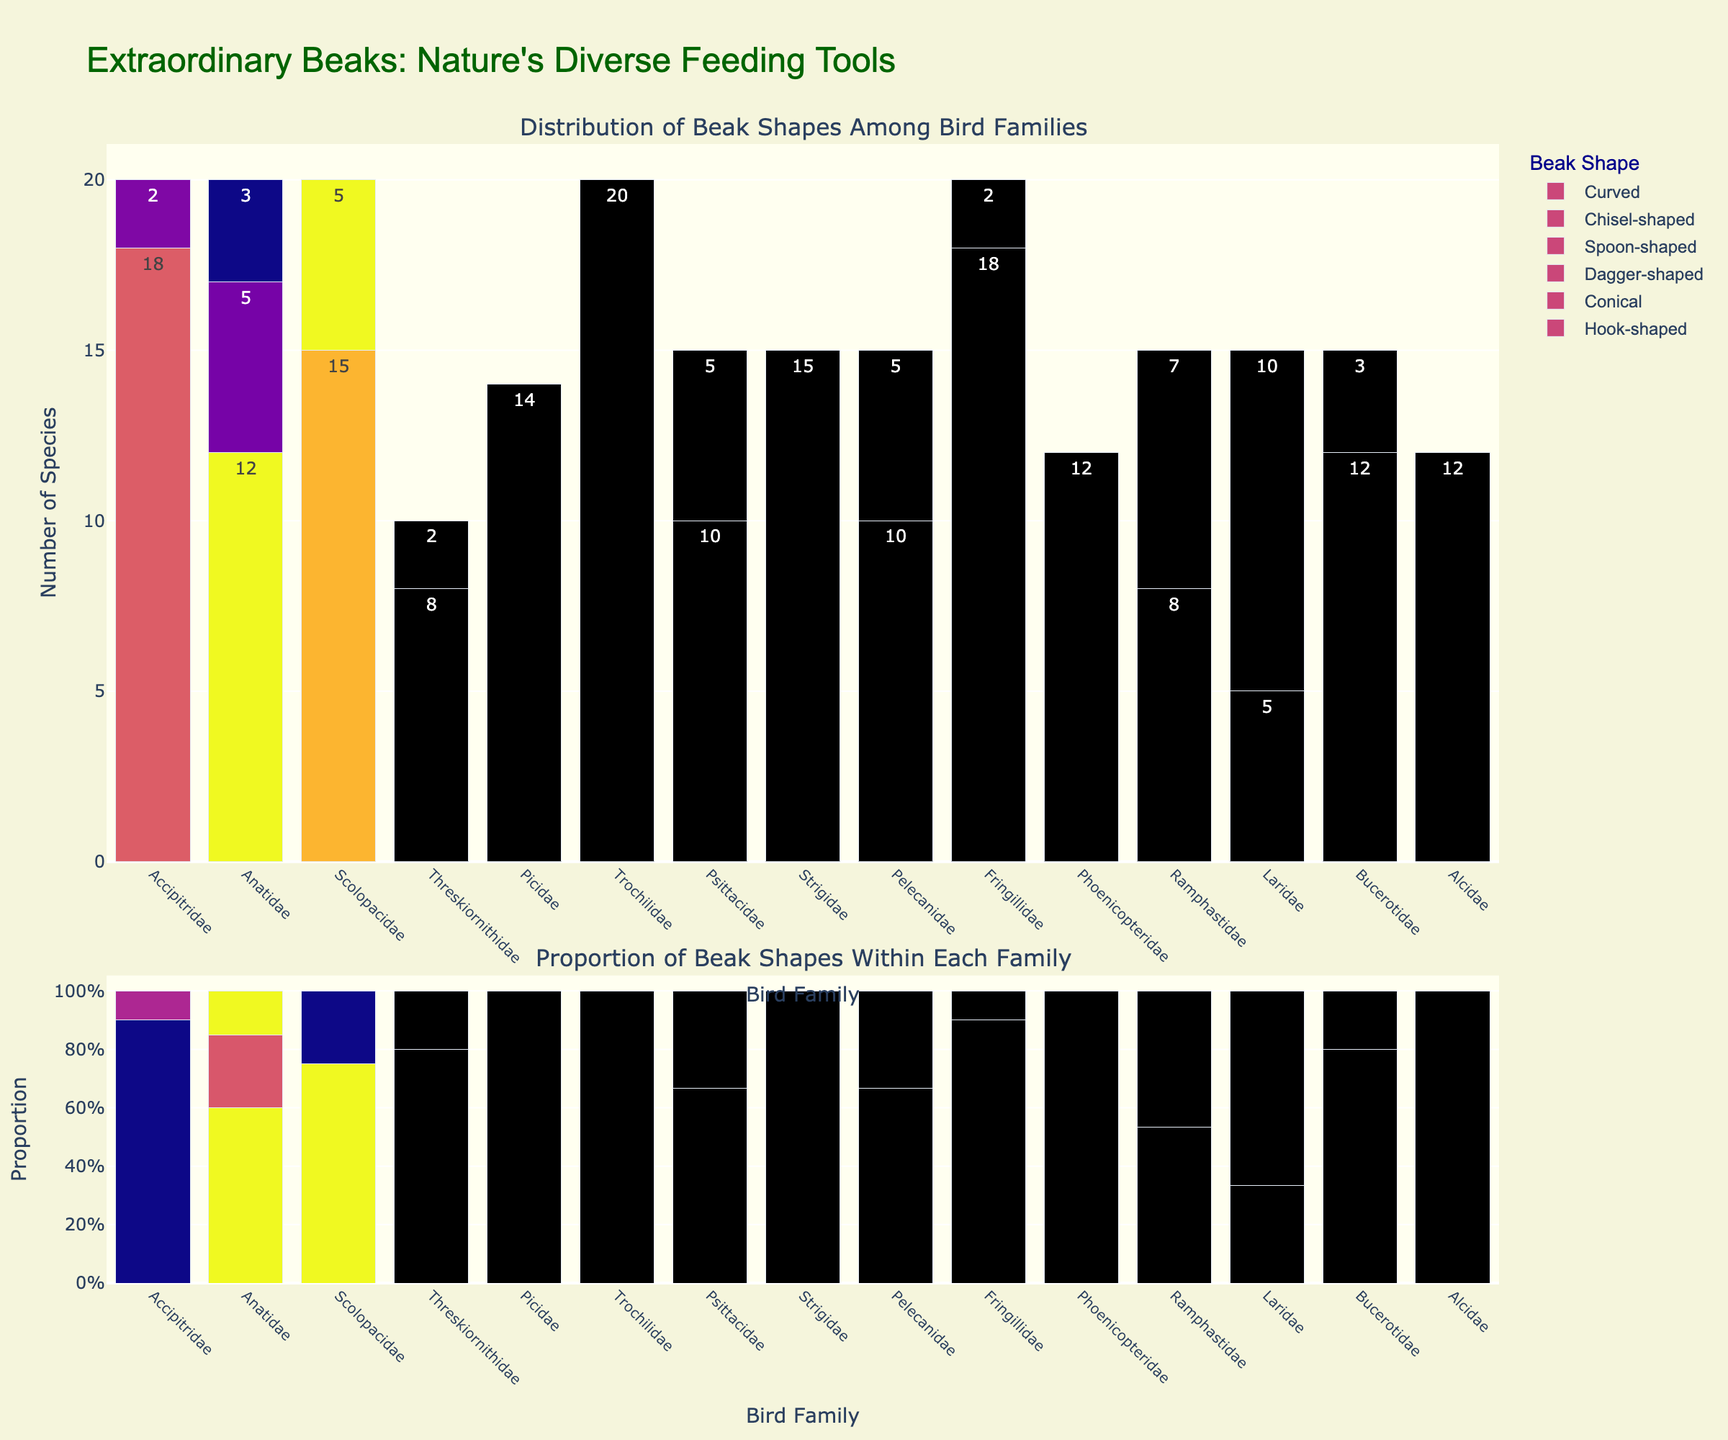What bird family has the highest number of species with spoon-shaped beaks? Look at the bar heights in the first subplot to identify which bird family has the tallest bar for spoon-shaped beaks. Threskiornithidae has the tallest bar for spoon-shaped beaks.
Answer: Threskiornithidae How many species in total have dagger-shaped beaks across all bird families? Sum the counts for dagger-shaped beaks from all bird families. The counts are 0, 0, 15, 0, 0, 0, 0, 0, 10, 0, 0, 0, 10, 0, 12. The total is 47.
Answer: 47 Which bird family has the highest proportion of species with a chisel-shaped beak within the family? Look at the proportions in the second subplot and identify which bird family has the highest proportion for chisel-shaped beaks. Picidae has the tallest bar in the second subplot for chisel-shaped beaks.
Answer: Picidae Among the families with conical beaks, which one has the fewest species, and how many species does it have? Compare the heights of the bars for conical beaks in the first subplot to find the shortest one. Psittacidae has the shortest bar with 5 species.
Answer: Psittacidae, 5 What is the combined number of species with hook-shaped beaks in Accipitridae and Strigidae? Add the counts for hook-shaped beaks in Accipitridae and Strigidae. Accipitridae has 18 and Strigidae has 15, so the total is 18 + 15 = 33.
Answer: 33 Which bird families have any species with curved beaks? Identify families with non-zero bars for curved beaks in the first subplot. The families are Accipitridae, Anatidae, Scolopacidae, Threskiornithidae, Trochilidae, Fringillidae, Phoenicopteridae, and Ramphastidae.
Answer: Accipitridae, Anatidae, Scolopacidae, Threskiornithidae, Trochilidae, Fringillidae, Phoenicopteridae, Ramphastidae Between the families Psittacidae and Fringillidae, which has a greater diversity of beak shapes and by how many shapes? Count the number of unique beak shapes in both families from the first subplot, then compare. Psittacidae has 2 shapes (hook-shaped, conical), and Fringillidae has 3 (hook-shaped, conical, curved). The difference is 3 - 2 = 1.
Answer: Fringillidae, 1 Which bird family has the highest number of unique beak shapes among the 6 given shapes? Check which family has non-zero counts for the most different beak shapes in the first subplot. Accipitridae, Anatidae, and Ramphastidae each have 2 unique beak shapes.
Answer: Accipitridae, Anatidae, Ramphastidae 